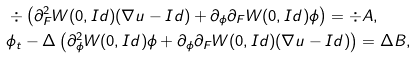<formula> <loc_0><loc_0><loc_500><loc_500>& \div \left ( \partial ^ { 2 } _ { F } W ( 0 , I d ) ( \nabla u - I d ) + \partial _ { \phi } \partial _ { F } W ( 0 , I d ) \phi \right ) = \div A , \\ & \phi _ { t } - \Delta \left ( \partial ^ { 2 } _ { \phi } W ( 0 , I d ) \phi + \partial _ { \phi } \partial _ { F } W ( 0 , I d ) ( \nabla u - I d ) \right ) = \Delta B ,</formula> 